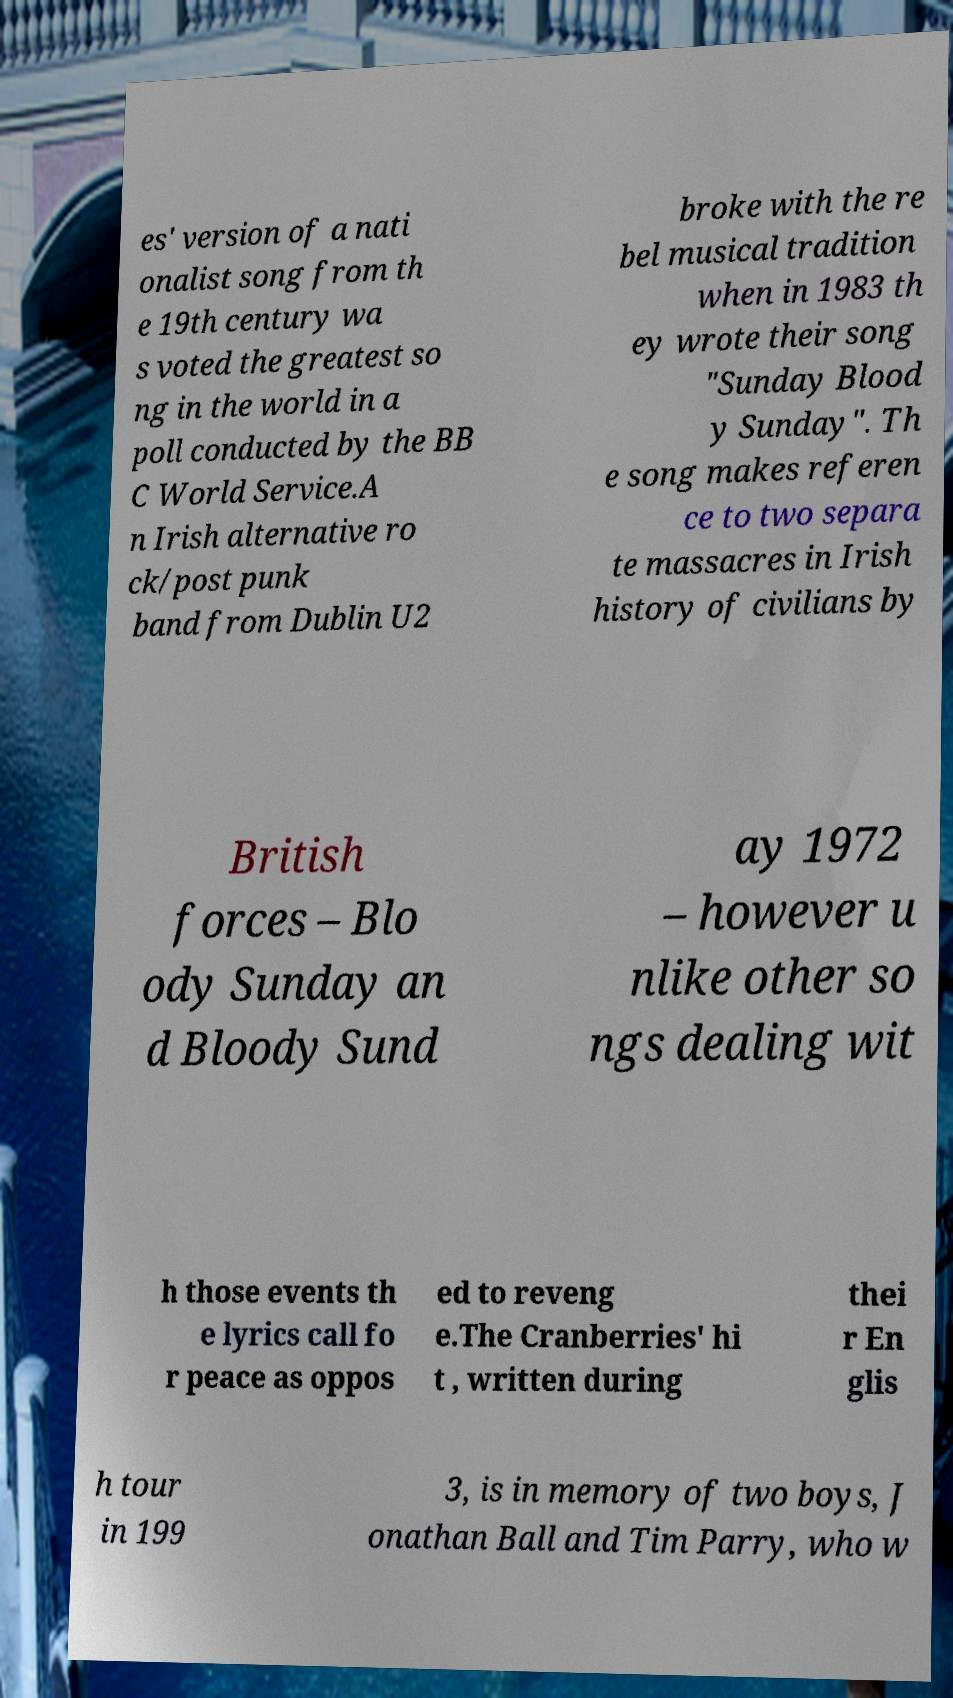What messages or text are displayed in this image? I need them in a readable, typed format. es' version of a nati onalist song from th e 19th century wa s voted the greatest so ng in the world in a poll conducted by the BB C World Service.A n Irish alternative ro ck/post punk band from Dublin U2 broke with the re bel musical tradition when in 1983 th ey wrote their song "Sunday Blood y Sunday". Th e song makes referen ce to two separa te massacres in Irish history of civilians by British forces – Blo ody Sunday an d Bloody Sund ay 1972 – however u nlike other so ngs dealing wit h those events th e lyrics call fo r peace as oppos ed to reveng e.The Cranberries' hi t , written during thei r En glis h tour in 199 3, is in memory of two boys, J onathan Ball and Tim Parry, who w 